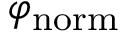Convert formula to latex. <formula><loc_0><loc_0><loc_500><loc_500>\varphi _ { n o r m }</formula> 